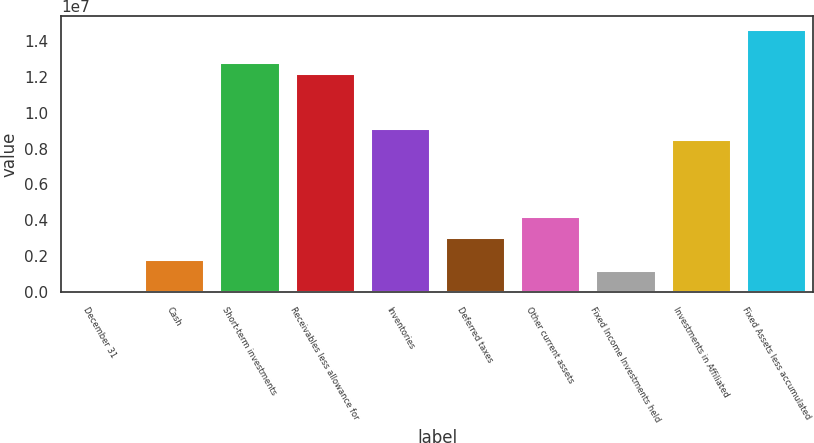<chart> <loc_0><loc_0><loc_500><loc_500><bar_chart><fcel>December 31<fcel>Cash<fcel>Short-term investments<fcel>Receivables less allowance for<fcel>Inventories<fcel>Deferred taxes<fcel>Other current assets<fcel>Fixed Income Investments held<fcel>Investments in Affiliated<fcel>Fixed Assets less accumulated<nl><fcel>2003<fcel>1.83063e+06<fcel>1.28024e+07<fcel>1.21928e+07<fcel>9.14513e+06<fcel>3.04971e+06<fcel>4.26879e+06<fcel>1.22109e+06<fcel>8.53558e+06<fcel>1.4631e+07<nl></chart> 